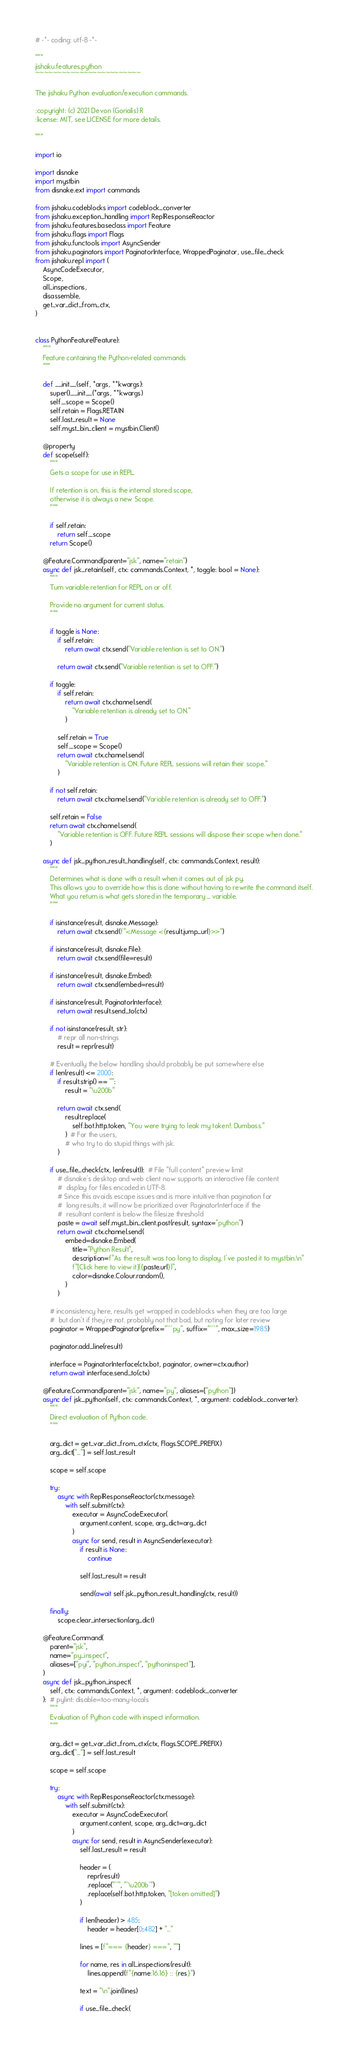<code> <loc_0><loc_0><loc_500><loc_500><_Python_># -*- coding: utf-8 -*-

"""
jishaku.features.python
~~~~~~~~~~~~~~~~~~~~~~~~

The jishaku Python evaluation/execution commands.

:copyright: (c) 2021 Devon (Gorialis) R
:license: MIT, see LICENSE for more details.

"""

import io

import disnake
import mystbin
from disnake.ext import commands

from jishaku.codeblocks import codeblock_converter
from jishaku.exception_handling import ReplResponseReactor
from jishaku.features.baseclass import Feature
from jishaku.flags import Flags
from jishaku.functools import AsyncSender
from jishaku.paginators import PaginatorInterface, WrappedPaginator, use_file_check
from jishaku.repl import (
    AsyncCodeExecutor,
    Scope,
    all_inspections,
    disassemble,
    get_var_dict_from_ctx,
)


class PythonFeature(Feature):
    """
    Feature containing the Python-related commands
    """

    def __init__(self, *args, **kwargs):
        super().__init__(*args, **kwargs)
        self._scope = Scope()
        self.retain = Flags.RETAIN
        self.last_result = None
        self.myst_bin_client = mystbin.Client()

    @property
    def scope(self):
        """
        Gets a scope for use in REPL.

        If retention is on, this is the internal stored scope,
        otherwise it is always a new Scope.
        """

        if self.retain:
            return self._scope
        return Scope()

    @Feature.Command(parent="jsk", name="retain")
    async def jsk_retain(self, ctx: commands.Context, *, toggle: bool = None):
        """
        Turn variable retention for REPL on or off.

        Provide no argument for current status.
        """

        if toggle is None:
            if self.retain:
                return await ctx.send("Variable retention is set to ON.")

            return await ctx.send("Variable retention is set to OFF.")

        if toggle:
            if self.retain:
                return await ctx.channel.send(
                    "Variable retention is already set to ON."
                )

            self.retain = True
            self._scope = Scope()
            return await ctx.channel.send(
                "Variable retention is ON. Future REPL sessions will retain their scope."
            )

        if not self.retain:
            return await ctx.channel.send("Variable retention is already set to OFF.")

        self.retain = False
        return await ctx.channel.send(
            "Variable retention is OFF. Future REPL sessions will dispose their scope when done."
        )

    async def jsk_python_result_handling(self, ctx: commands.Context, result):
        """
        Determines what is done with a result when it comes out of jsk py.
        This allows you to override how this is done without having to rewrite the command itself.
        What you return is what gets stored in the temporary _ variable.
        """

        if isinstance(result, disnake.Message):
            return await ctx.send(f"<Message <{result.jump_url}>>")

        if isinstance(result, disnake.File):
            return await ctx.send(file=result)

        if isinstance(result, disnake.Embed):
            return await ctx.send(embed=result)

        if isinstance(result, PaginatorInterface):
            return await result.send_to(ctx)

        if not isinstance(result, str):
            # repr all non-strings
            result = repr(result)

        # Eventually the below handling should probably be put somewhere else
        if len(result) <= 2000:
            if result.strip() == "":
                result = "\u200b"

            return await ctx.send(
                result.replace(
                    self.bot.http.token, "You were trying to leak my token!. Dumbass."
                )  # For the users,
                # who try to do stupid things with jsk.
            )

        if use_file_check(ctx, len(result)):  # File "full content" preview limit
            # disnake's desktop and web client now supports an interactive file content
            #  display for files encoded in UTF-8.
            # Since this avoids escape issues and is more intuitive than pagination for
            #  long results, it will now be prioritized over PaginatorInterface if the
            #  resultant content is below the filesize threshold
            paste = await self.myst_bin_client.post(result, syntax="python")
            return await ctx.channel.send(
                embed=disnake.Embed(
                    title="Python Result",
                    description=f"As the result was too long to display, I've posted it to mystbin.\n"
                    f"[Click here to view it]({paste.url})",
                    color=disnake.Colour.random(),
                )
            )

        # inconsistency here, results get wrapped in codeblocks when they are too large
        #  but don't if they're not. probably not that bad, but noting for later review
        paginator = WrappedPaginator(prefix="```py", suffix="```", max_size=1985)

        paginator.add_line(result)

        interface = PaginatorInterface(ctx.bot, paginator, owner=ctx.author)
        return await interface.send_to(ctx)

    @Feature.Command(parent="jsk", name="py", aliases=["python"])
    async def jsk_python(self, ctx: commands.Context, *, argument: codeblock_converter):
        """
        Direct evaluation of Python code.
        """

        arg_dict = get_var_dict_from_ctx(ctx, Flags.SCOPE_PREFIX)
        arg_dict["_"] = self.last_result

        scope = self.scope

        try:
            async with ReplResponseReactor(ctx.message):
                with self.submit(ctx):
                    executor = AsyncCodeExecutor(
                        argument.content, scope, arg_dict=arg_dict
                    )
                    async for send, result in AsyncSender(executor):
                        if result is None:
                            continue

                        self.last_result = result

                        send(await self.jsk_python_result_handling(ctx, result))

        finally:
            scope.clear_intersection(arg_dict)

    @Feature.Command(
        parent="jsk",
        name="py_inspect",
        aliases=["pyi", "python_inspect", "pythoninspect"],
    )
    async def jsk_python_inspect(
        self, ctx: commands.Context, *, argument: codeblock_converter
    ):  # pylint: disable=too-many-locals
        """
        Evaluation of Python code with inspect information.
        """

        arg_dict = get_var_dict_from_ctx(ctx, Flags.SCOPE_PREFIX)
        arg_dict["_"] = self.last_result

        scope = self.scope

        try:
            async with ReplResponseReactor(ctx.message):
                with self.submit(ctx):
                    executor = AsyncCodeExecutor(
                        argument.content, scope, arg_dict=arg_dict
                    )
                    async for send, result in AsyncSender(executor):
                        self.last_result = result

                        header = (
                            repr(result)
                            .replace("``", "`\u200b`")
                            .replace(self.bot.http.token, "[token omitted]")
                        )

                        if len(header) > 485:
                            header = header[0:482] + "..."

                        lines = [f"=== {header} ===", ""]

                        for name, res in all_inspections(result):
                            lines.append(f"{name:16.16} :: {res}")

                        text = "\n".join(lines)

                        if use_file_check(</code> 